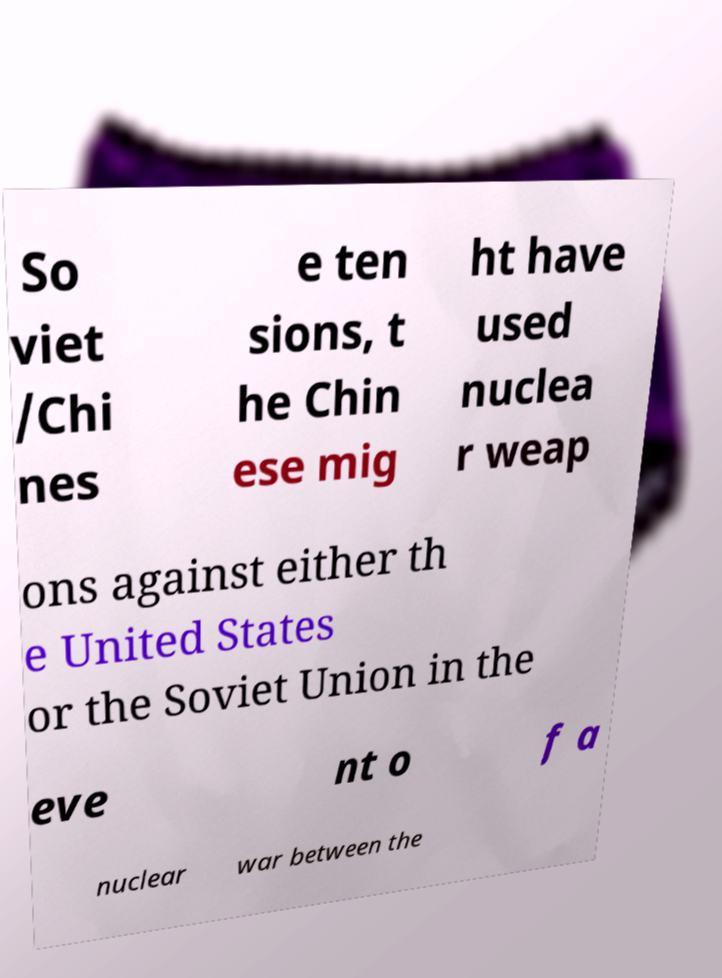Please read and relay the text visible in this image. What does it say? So viet /Chi nes e ten sions, t he Chin ese mig ht have used nuclea r weap ons against either th e United States or the Soviet Union in the eve nt o f a nuclear war between the 